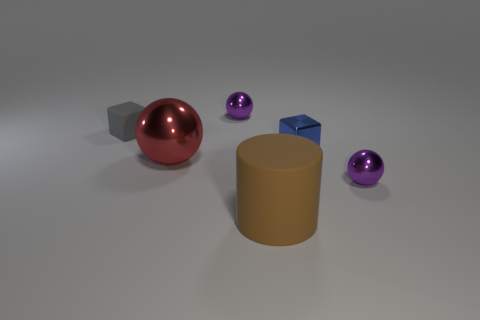Subtract all purple spheres. How many spheres are left? 1 Add 1 tiny purple metallic things. How many objects exist? 7 Subtract 0 red cubes. How many objects are left? 6 Subtract all blocks. How many objects are left? 4 Subtract all big yellow cylinders. Subtract all big cylinders. How many objects are left? 5 Add 6 blue shiny things. How many blue shiny things are left? 7 Add 5 big brown objects. How many big brown objects exist? 6 